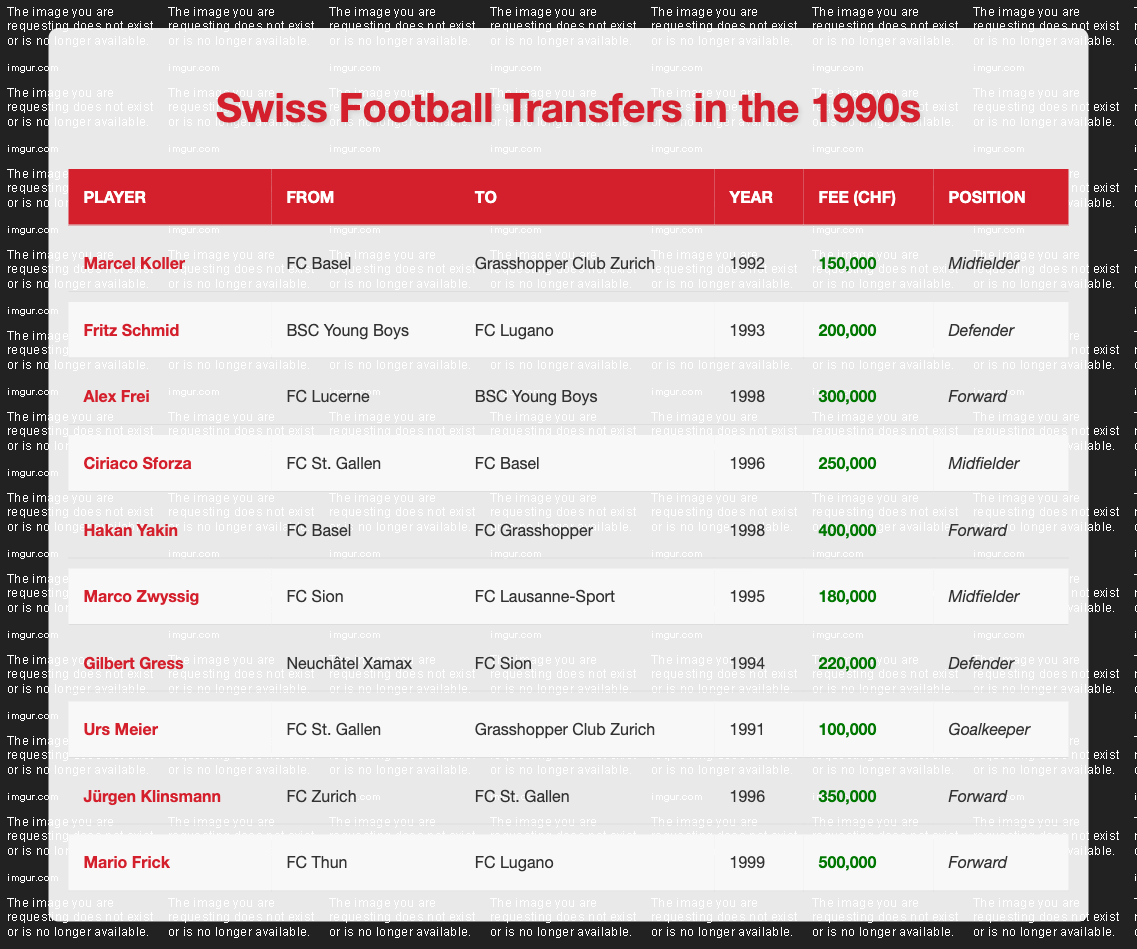What year did Marcel Koller transfer to Grasshopper Club Zurich? The table shows that Marcel Koller transferred in the year 1992.
Answer: 1992 Which player had the highest transfer fee? The player with the highest transfer fee is Mario Frick with a fee of 500,000 CHF, as displayed in the table.
Answer: Mario Frick How many defenders transferred during the 1990s? The table lists 3 defenders: Fritz Schmid, Gilbert Gress, and Ciriaco Sforza, so the total is 3.
Answer: 3 Did Alex Frei play as a midfielder? The table indicates that Alex Frei is listed as a Forward, not a Midfielder, so the statement is false.
Answer: No In which year did Hakan Yakin transfer, and what was the transfer fee? The table shows Hakan Yakin transferred in 1998 for a fee of 400,000 CHF.
Answer: 1998, 400,000 CHF What is the average transfer fee for defenders? The transfer fees for defenders (Fritz Schmid, Gilbert Gress) are 200,000 and 220,000 CHF respectively. Their average is (200,000 + 220,000) / 2 = 210,000 CHF.
Answer: 210,000 CHF How many players transferred from FC Basel? The table lists 3 players who transferred from FC Basel: Marcel Koller, Hakan Yakin, and Ciriaco Sforza.
Answer: 3 What position did the player with the highest transfer fee play? Mario Frick, who had the highest transfer fee of 500,000 CHF, played as a Forward according to the table.
Answer: Forward Which club did Jürgen Klinsmann transfer to and in which year? Jürgen Klinsmann transferred to FC St. Gallen in 1996 as per the table information.
Answer: FC St. Gallen, 1996 Was there a transfer from FC Sion to FC Lausanne-Sport? According to the table, Marco Zwyssig transferred from FC Sion to FC Lausanne-Sport, so the statement is true.
Answer: Yes What are the total transfer fees for players moving to FC Lugano? Alex Frei and Mario Frick moved to FC Lugano for fees of 300,000 and 500,000 CHF. Their total is 300,000 + 500,000 = 800,000 CHF.
Answer: 800,000 CHF 